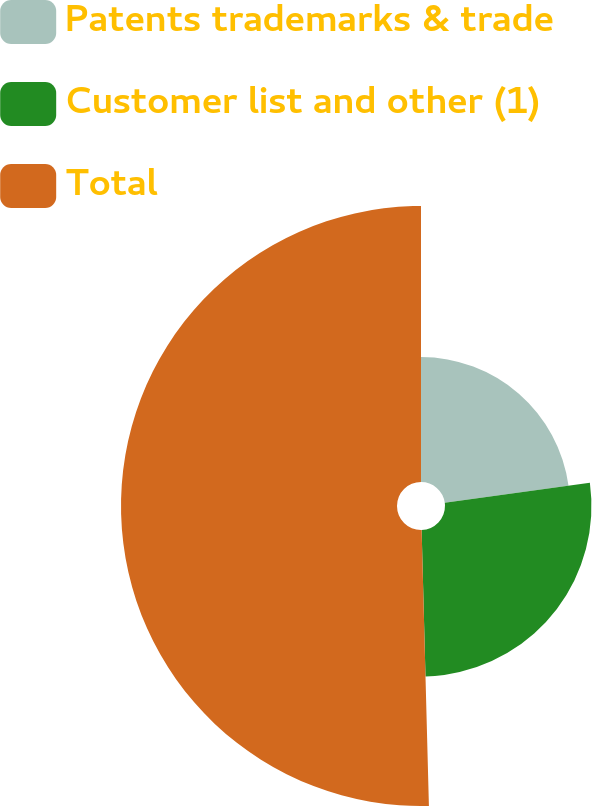<chart> <loc_0><loc_0><loc_500><loc_500><pie_chart><fcel>Patents trademarks & trade<fcel>Customer list and other (1)<fcel>Total<nl><fcel>22.82%<fcel>26.76%<fcel>50.42%<nl></chart> 